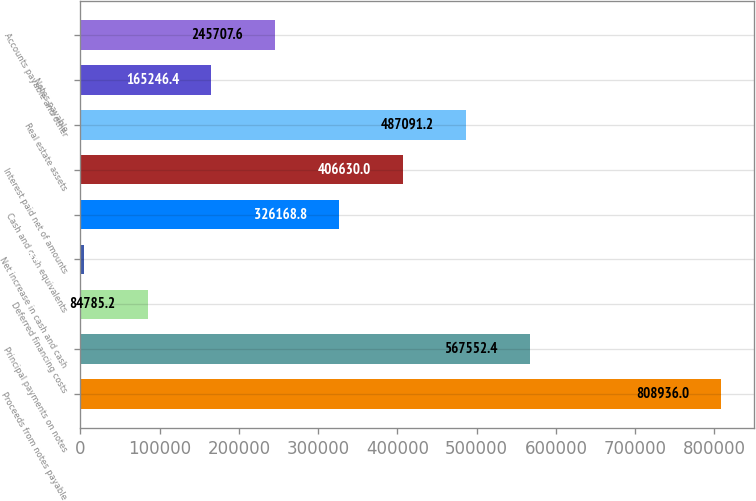Convert chart to OTSL. <chart><loc_0><loc_0><loc_500><loc_500><bar_chart><fcel>Proceeds from notes payable<fcel>Principal payments on notes<fcel>Deferred financing costs<fcel>Net increase in cash and cash<fcel>Cash and cash equivalents<fcel>Interest paid net of amounts<fcel>Real estate assets<fcel>Notes payable<fcel>Accounts payable and other<nl><fcel>808936<fcel>567552<fcel>84785.2<fcel>4324<fcel>326169<fcel>406630<fcel>487091<fcel>165246<fcel>245708<nl></chart> 